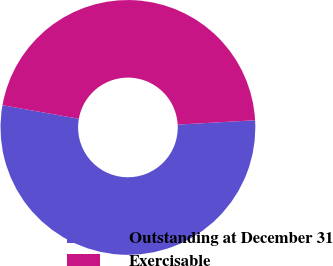<chart> <loc_0><loc_0><loc_500><loc_500><pie_chart><fcel>Outstanding at December 31<fcel>Exercisable<nl><fcel>53.69%<fcel>46.31%<nl></chart> 